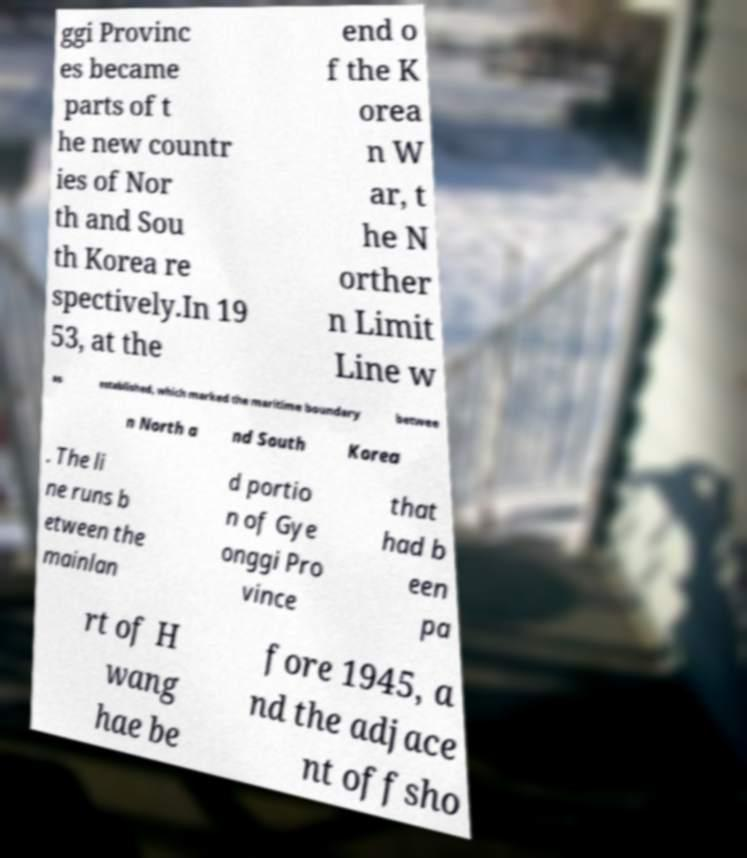For documentation purposes, I need the text within this image transcribed. Could you provide that? ggi Provinc es became parts of t he new countr ies of Nor th and Sou th Korea re spectively.In 19 53, at the end o f the K orea n W ar, t he N orther n Limit Line w as established, which marked the maritime boundary betwee n North a nd South Korea . The li ne runs b etween the mainlan d portio n of Gye onggi Pro vince that had b een pa rt of H wang hae be fore 1945, a nd the adjace nt offsho 